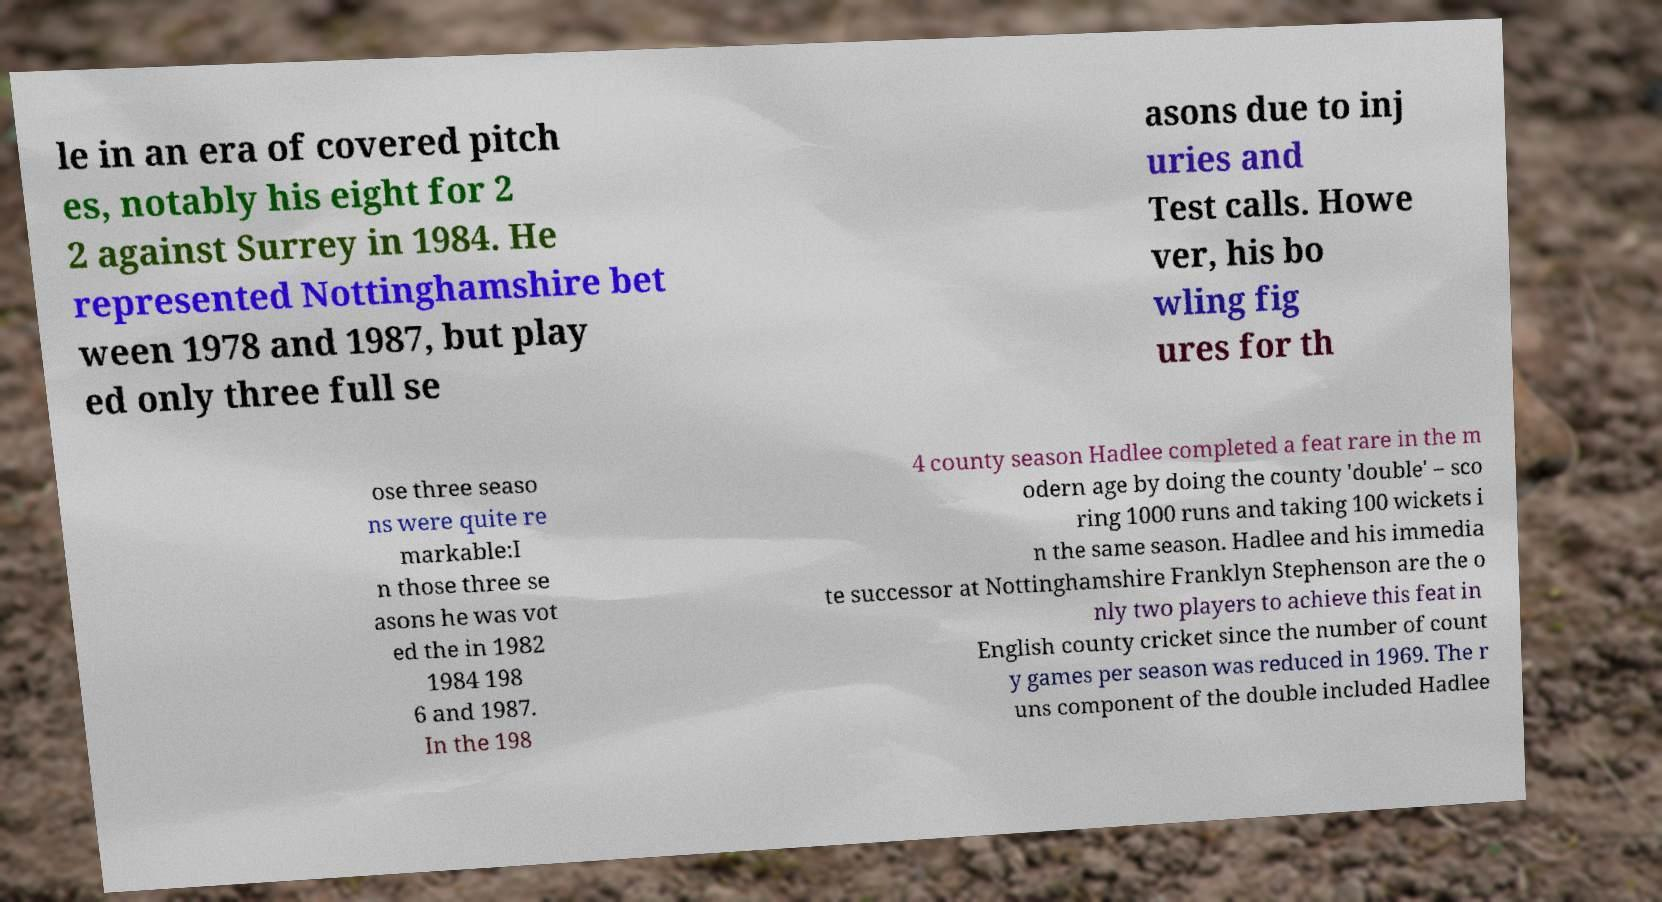What messages or text are displayed in this image? I need them in a readable, typed format. le in an era of covered pitch es, notably his eight for 2 2 against Surrey in 1984. He represented Nottinghamshire bet ween 1978 and 1987, but play ed only three full se asons due to inj uries and Test calls. Howe ver, his bo wling fig ures for th ose three seaso ns were quite re markable:I n those three se asons he was vot ed the in 1982 1984 198 6 and 1987. In the 198 4 county season Hadlee completed a feat rare in the m odern age by doing the county 'double' – sco ring 1000 runs and taking 100 wickets i n the same season. Hadlee and his immedia te successor at Nottinghamshire Franklyn Stephenson are the o nly two players to achieve this feat in English county cricket since the number of count y games per season was reduced in 1969. The r uns component of the double included Hadlee 